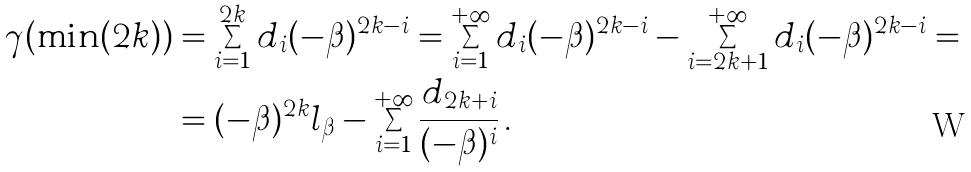<formula> <loc_0><loc_0><loc_500><loc_500>\gamma ( \min ( 2 k ) ) & = \sum _ { i = 1 } ^ { 2 k } d _ { i } ( - \beta ) ^ { 2 k - i } = \sum _ { i = 1 } ^ { + \infty } d _ { i } ( - \beta ) ^ { 2 k - i } - \sum _ { i = 2 k + 1 } ^ { + \infty } d _ { i } ( - \beta ) ^ { 2 k - i } = \\ & = ( - \beta ) ^ { 2 k } l _ { \beta } - \sum _ { i = 1 } ^ { + \infty } \frac { d _ { 2 k + i } } { ( - \beta ) ^ { i } } \, .</formula> 